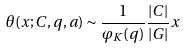<formula> <loc_0><loc_0><loc_500><loc_500>\theta ( x ; C , q , a ) \sim \frac { 1 } { \varphi _ { K } ( q ) } \frac { | C | } { | G | } x</formula> 